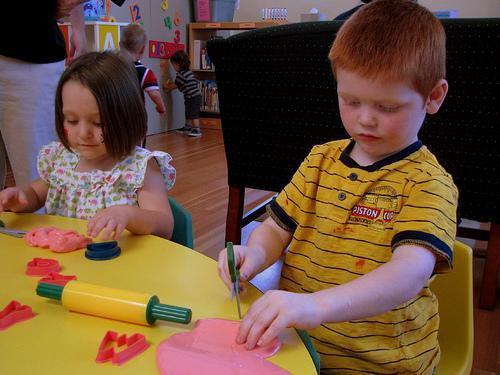How many people can be seen?
Give a very brief answer. 3. 